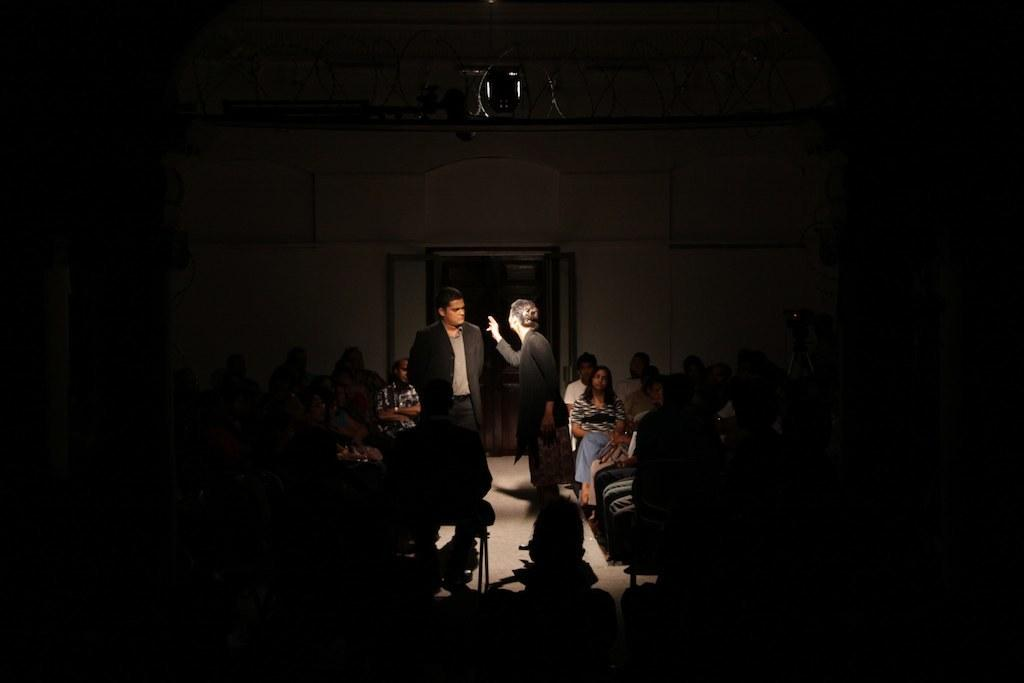How many people are in the image? There are people in the image, but the exact number is not specified. What are the people in the image doing? The people are sitting and standing in a room. What type of stocking is the person wearing in the image? There is no information about any stockings being worn by the people in the image. What scientific theory is being discussed by the people in the image? There is no information about any scientific theories being discussed by the people in the image. 